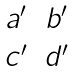Convert formula to latex. <formula><loc_0><loc_0><loc_500><loc_500>\begin{matrix} a ^ { \prime } & b ^ { \prime } \\ c ^ { \prime } & d ^ { \prime } \end{matrix}</formula> 